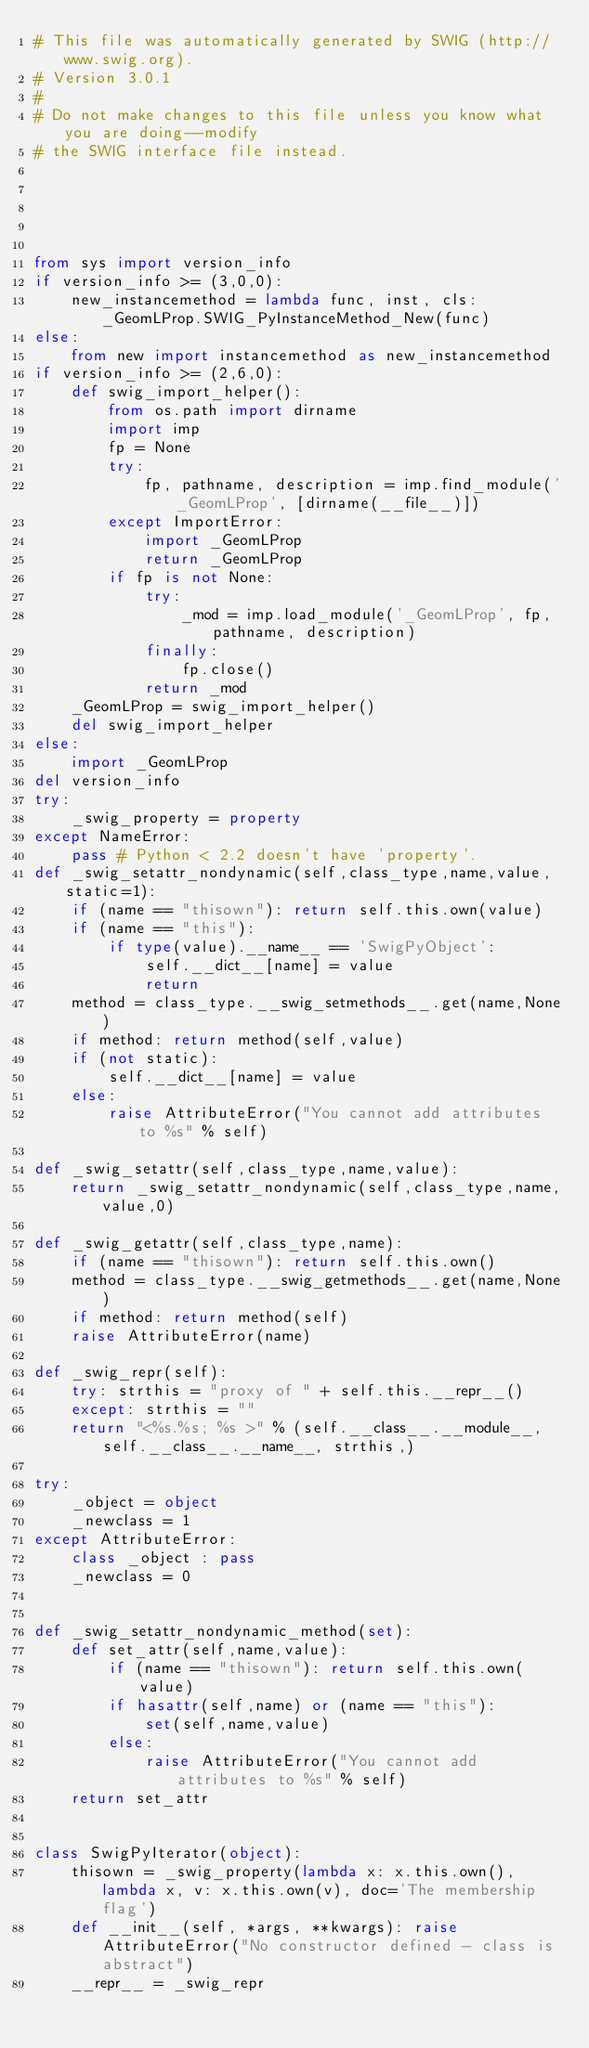<code> <loc_0><loc_0><loc_500><loc_500><_Python_># This file was automatically generated by SWIG (http://www.swig.org).
# Version 3.0.1
#
# Do not make changes to this file unless you know what you are doing--modify
# the SWIG interface file instead.





from sys import version_info
if version_info >= (3,0,0):
    new_instancemethod = lambda func, inst, cls: _GeomLProp.SWIG_PyInstanceMethod_New(func)
else:
    from new import instancemethod as new_instancemethod
if version_info >= (2,6,0):
    def swig_import_helper():
        from os.path import dirname
        import imp
        fp = None
        try:
            fp, pathname, description = imp.find_module('_GeomLProp', [dirname(__file__)])
        except ImportError:
            import _GeomLProp
            return _GeomLProp
        if fp is not None:
            try:
                _mod = imp.load_module('_GeomLProp', fp, pathname, description)
            finally:
                fp.close()
            return _mod
    _GeomLProp = swig_import_helper()
    del swig_import_helper
else:
    import _GeomLProp
del version_info
try:
    _swig_property = property
except NameError:
    pass # Python < 2.2 doesn't have 'property'.
def _swig_setattr_nondynamic(self,class_type,name,value,static=1):
    if (name == "thisown"): return self.this.own(value)
    if (name == "this"):
        if type(value).__name__ == 'SwigPyObject':
            self.__dict__[name] = value
            return
    method = class_type.__swig_setmethods__.get(name,None)
    if method: return method(self,value)
    if (not static):
        self.__dict__[name] = value
    else:
        raise AttributeError("You cannot add attributes to %s" % self)

def _swig_setattr(self,class_type,name,value):
    return _swig_setattr_nondynamic(self,class_type,name,value,0)

def _swig_getattr(self,class_type,name):
    if (name == "thisown"): return self.this.own()
    method = class_type.__swig_getmethods__.get(name,None)
    if method: return method(self)
    raise AttributeError(name)

def _swig_repr(self):
    try: strthis = "proxy of " + self.this.__repr__()
    except: strthis = ""
    return "<%s.%s; %s >" % (self.__class__.__module__, self.__class__.__name__, strthis,)

try:
    _object = object
    _newclass = 1
except AttributeError:
    class _object : pass
    _newclass = 0


def _swig_setattr_nondynamic_method(set):
    def set_attr(self,name,value):
        if (name == "thisown"): return self.this.own(value)
        if hasattr(self,name) or (name == "this"):
            set(self,name,value)
        else:
            raise AttributeError("You cannot add attributes to %s" % self)
    return set_attr


class SwigPyIterator(object):
    thisown = _swig_property(lambda x: x.this.own(), lambda x, v: x.this.own(v), doc='The membership flag')
    def __init__(self, *args, **kwargs): raise AttributeError("No constructor defined - class is abstract")
    __repr__ = _swig_repr</code> 